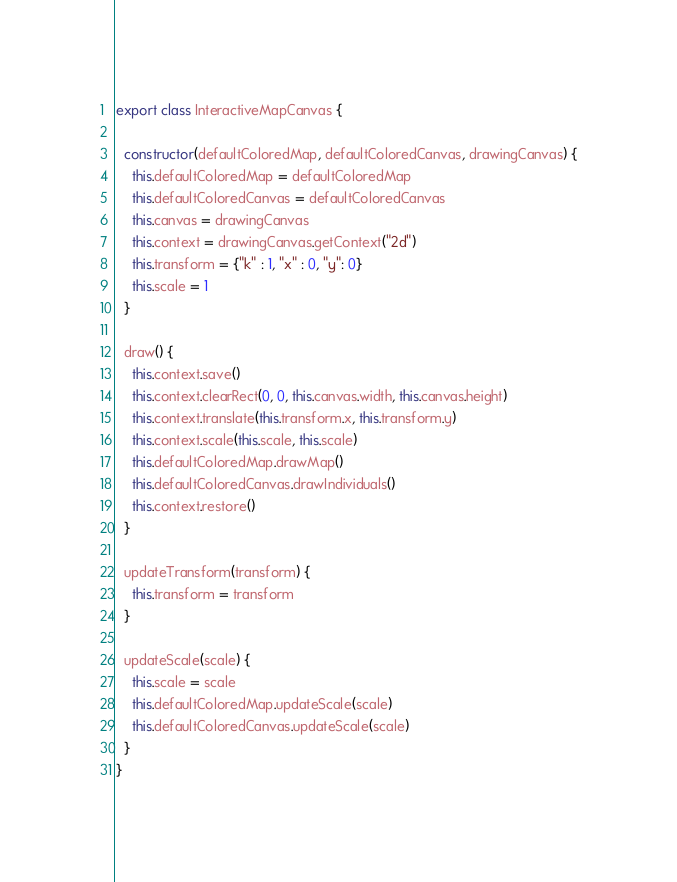<code> <loc_0><loc_0><loc_500><loc_500><_JavaScript_>export class InteractiveMapCanvas {
  
  constructor(defaultColoredMap, defaultColoredCanvas, drawingCanvas) {
    this.defaultColoredMap = defaultColoredMap
    this.defaultColoredCanvas = defaultColoredCanvas
    this.canvas = drawingCanvas
    this.context = drawingCanvas.getContext("2d")
    this.transform = {"k" : 1, "x" : 0, "y": 0}
    this.scale = 1
  }
  
  draw() {
    this.context.save()
    this.context.clearRect(0, 0, this.canvas.width, this.canvas.height)
    this.context.translate(this.transform.x, this.transform.y)
    this.context.scale(this.scale, this.scale)
    this.defaultColoredMap.drawMap()
    this.defaultColoredCanvas.drawIndividuals()
    this.context.restore()
  }
  
  updateTransform(transform) {
    this.transform = transform
  }
  
  updateScale(scale) {
    this.scale = scale
    this.defaultColoredMap.updateScale(scale)
    this.defaultColoredCanvas.updateScale(scale)
  }
}</code> 